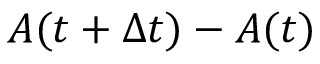Convert formula to latex. <formula><loc_0><loc_0><loc_500><loc_500>A ( t + \Delta t ) - A ( t )</formula> 